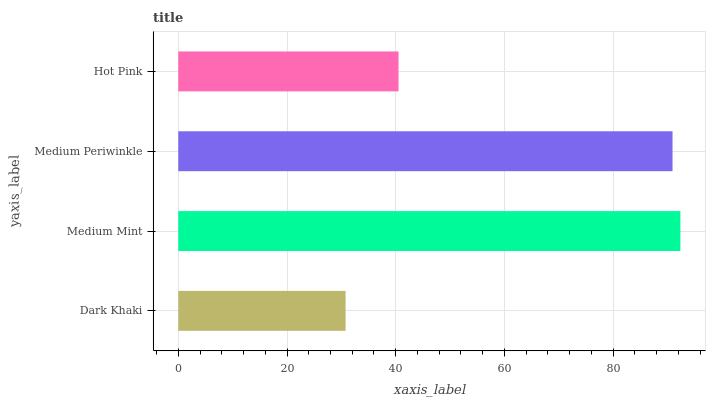Is Dark Khaki the minimum?
Answer yes or no. Yes. Is Medium Mint the maximum?
Answer yes or no. Yes. Is Medium Periwinkle the minimum?
Answer yes or no. No. Is Medium Periwinkle the maximum?
Answer yes or no. No. Is Medium Mint greater than Medium Periwinkle?
Answer yes or no. Yes. Is Medium Periwinkle less than Medium Mint?
Answer yes or no. Yes. Is Medium Periwinkle greater than Medium Mint?
Answer yes or no. No. Is Medium Mint less than Medium Periwinkle?
Answer yes or no. No. Is Medium Periwinkle the high median?
Answer yes or no. Yes. Is Hot Pink the low median?
Answer yes or no. Yes. Is Hot Pink the high median?
Answer yes or no. No. Is Medium Mint the low median?
Answer yes or no. No. 